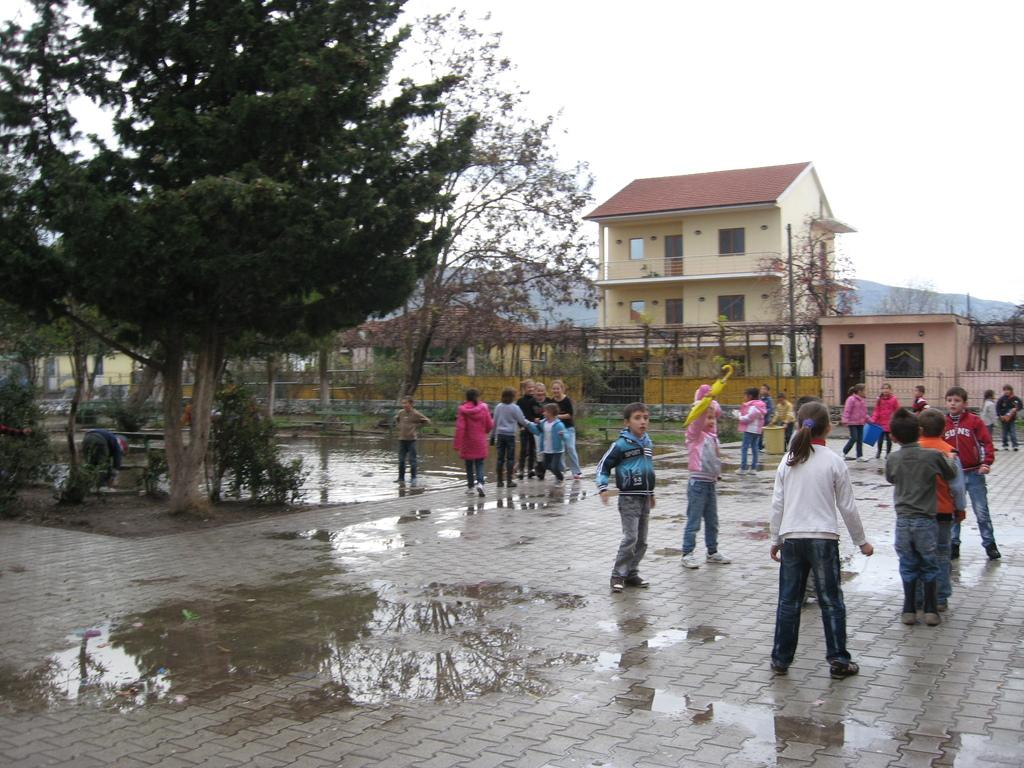What can be seen on the floor in the image? There are children standing on the floor in the image. What type of structures are present in the image? There are fences, buildings, and trees in the image. What type of natural feature is visible in the image? There are hills in the image. What part of the natural environment is visible in the image? The sky is visible in the image. What type of vegetable is being used as a doctor's alarm in the image? There is no vegetable, doctor, or alarm present in the image. 